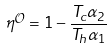Convert formula to latex. <formula><loc_0><loc_0><loc_500><loc_500>\eta ^ { \mathcal { O } } = 1 - \frac { T _ { c } \alpha _ { 2 } } { T _ { h } \alpha _ { 1 } }</formula> 